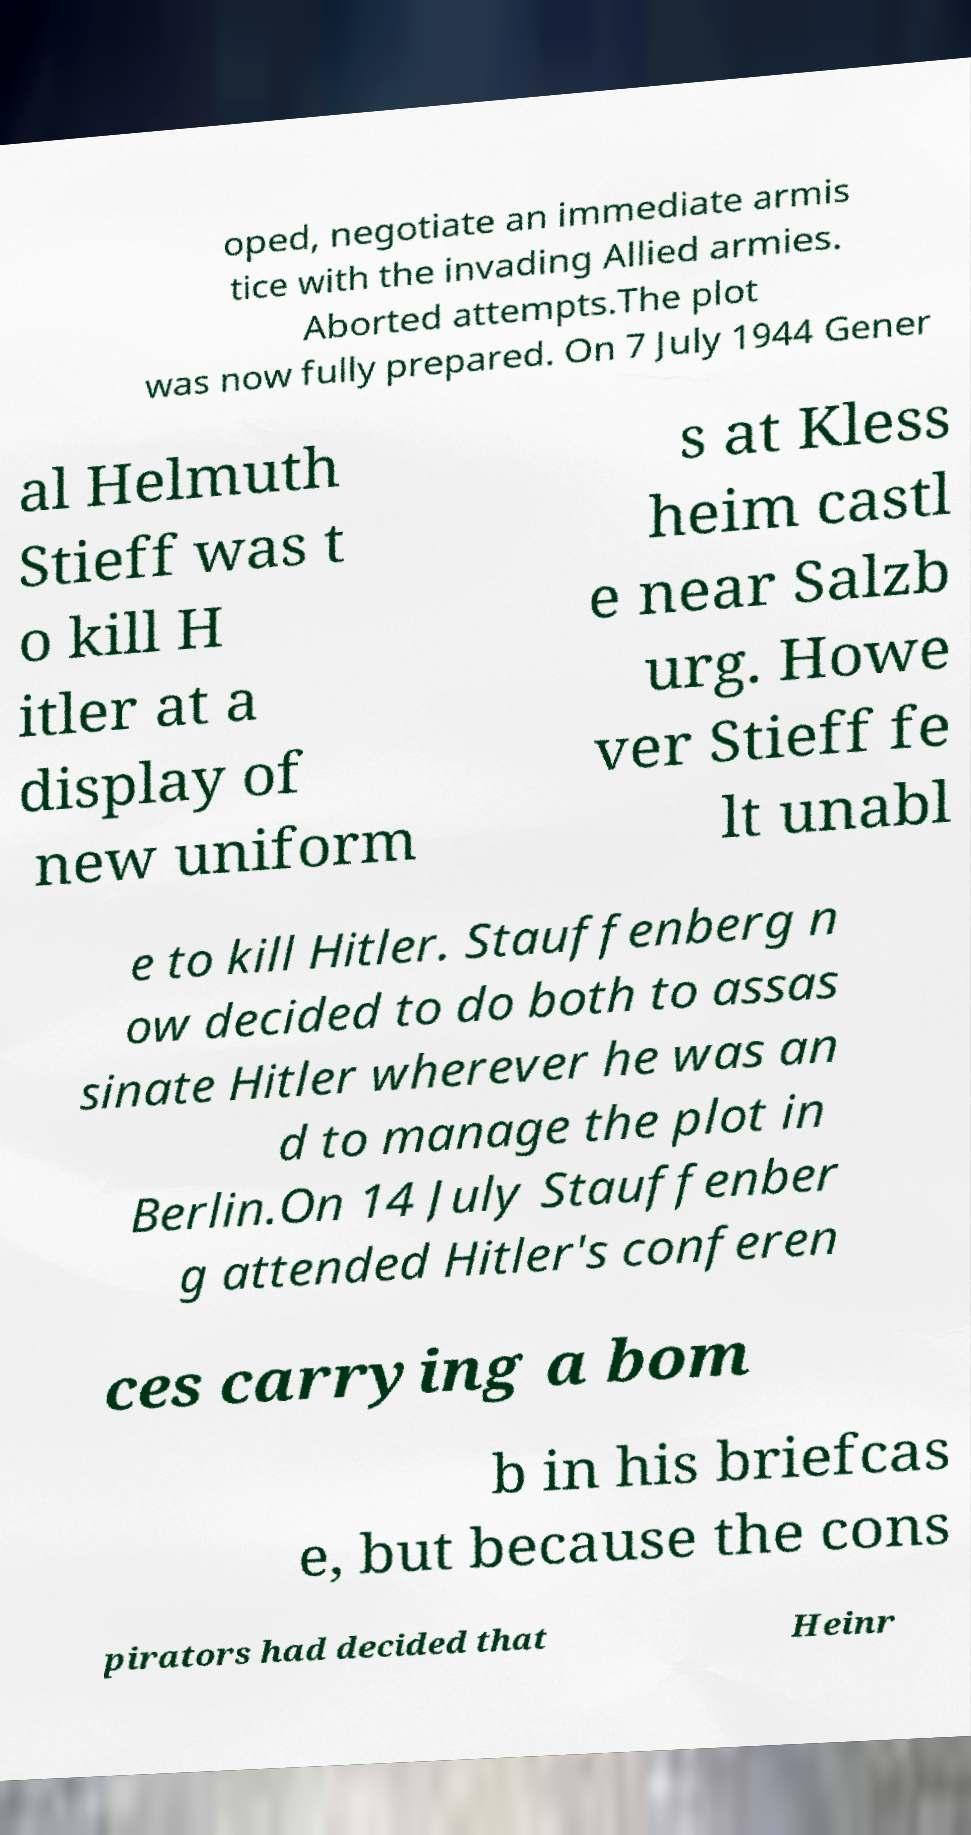Could you extract and type out the text from this image? oped, negotiate an immediate armis tice with the invading Allied armies. Aborted attempts.The plot was now fully prepared. On 7 July 1944 Gener al Helmuth Stieff was t o kill H itler at a display of new uniform s at Kless heim castl e near Salzb urg. Howe ver Stieff fe lt unabl e to kill Hitler. Stauffenberg n ow decided to do both to assas sinate Hitler wherever he was an d to manage the plot in Berlin.On 14 July Stauffenber g attended Hitler's conferen ces carrying a bom b in his briefcas e, but because the cons pirators had decided that Heinr 